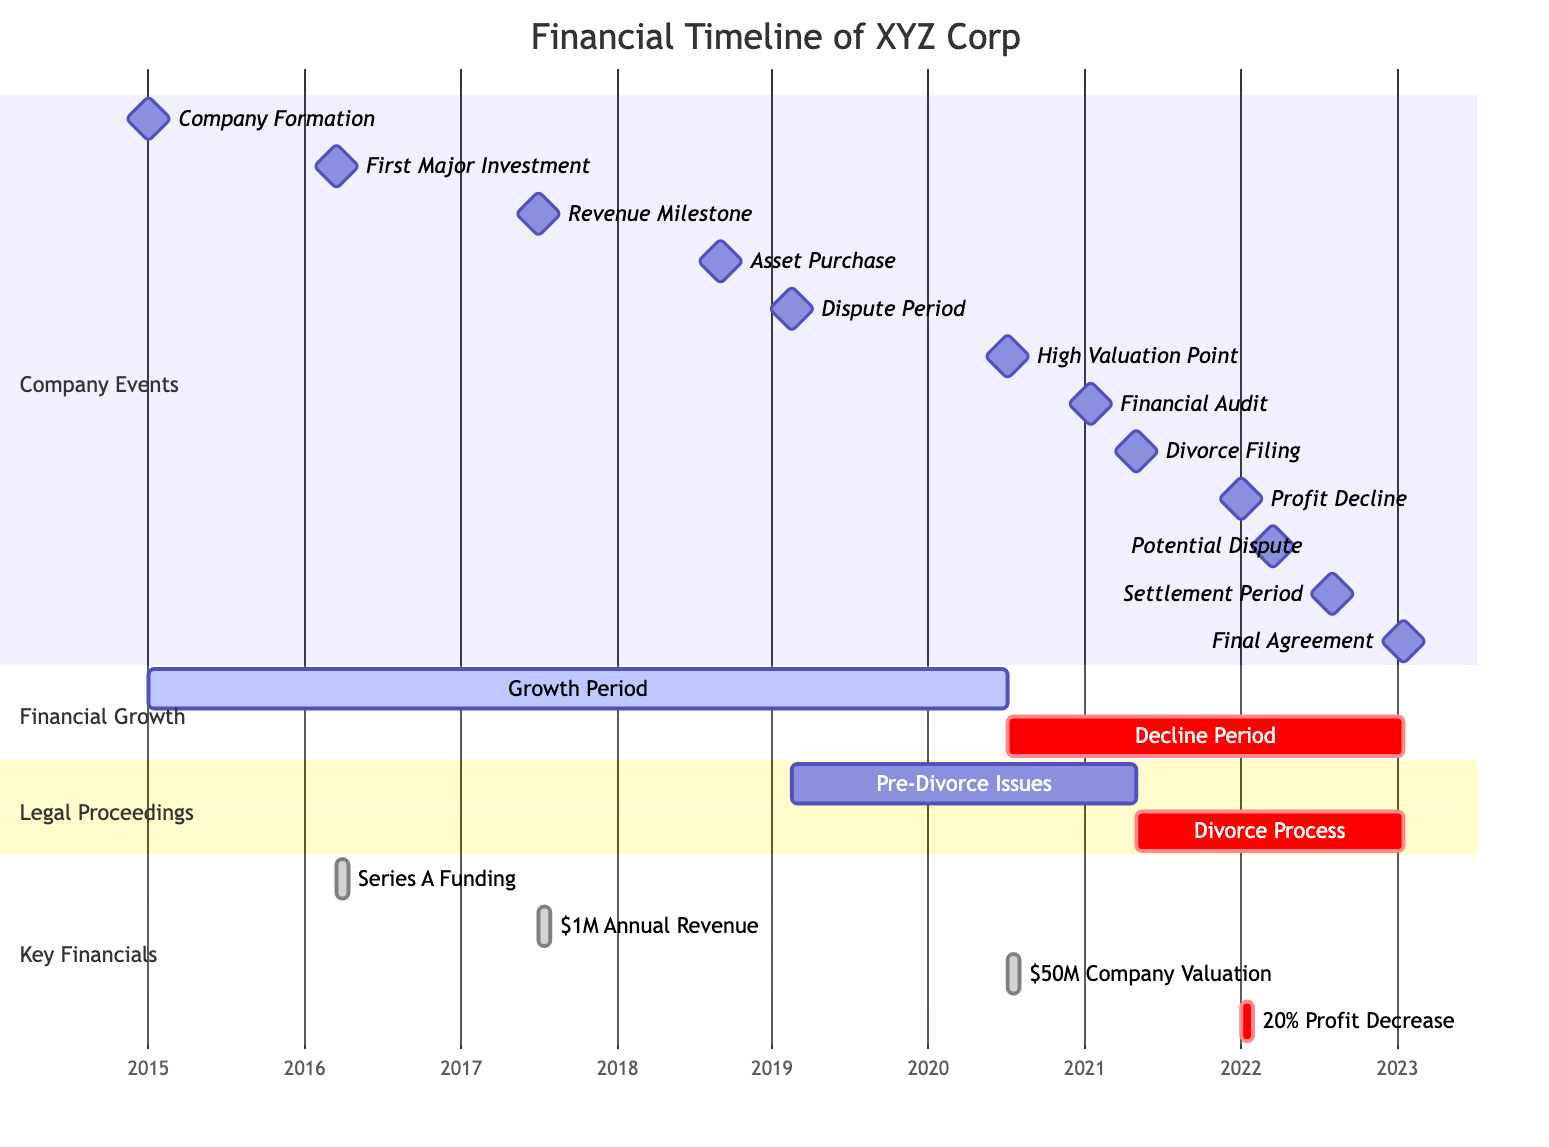What is the year of the company's formation? The diagram clearly indicates the company formation date marked as a milestone, which is noted as January 1, 2015.
Answer: 2015 Which event happened immediately after the first major investment? The first major investment occurred on March 15, 2016, followed by the revenue milestone, which was achieved on June 30, 2017. Thus, the revenue milestone is the event that directly followed the investment.
Answer: Revenue Milestone What is the duration of the decline period? The decline period starts from July 1, 2020, to January 15, 2023. To find the duration, we calculate the time between these two dates. This results in a total duration of about 2 years and 6.5 months (July 2020 to January 2023).
Answer: 2 years and 6.5 months How many critical periods are shown in the diagram? The diagram includes a section labeled "Financial Growth" which notes 'Decline Period' as critical, and within "Key Financials," there is a '20% Profit Decrease' noted as critical. Additionally, "Divorce Process" is marked as critical. Thus, we can count three periods classified as critical.
Answer: 3 What major event coincides with the divorce filing? The divorce filing is marked as May 1, 2021. The preceding milestone of 'Financial Audit' occurred on January 15, 2021, and the 'Profit Decline' happens at the end of the same year. Therefore, the 'Divorce Process' begins on the filing date, indicating it's directly related to the couple's legal situation.
Answer: Divorce Process What is the financial status right before the potential dispute? The potential dispute is scheduled for March 15, 2022. Leading up to this, the most relevant event before this date is the profit decline which was recorded on December 31, 2021. Therefore, the financial status before the potential dispute reflects a declining profitability context.
Answer: Profit Decline What was the company's valuation at its high point? The high valuation point is specifically stated as July 1, 2020, and it notes a company valuation of $50M at that date. This milestone encapsulates the apex of the company's financial valuation.
Answer: $50M Which sections of the diagram depict overlapping timelines? The "Legal Proceedings" and "Financial Growth" sections overlap in terms of timeline events with critical junctures drawn across many milestones intersecting, particularly around bankruptcy, disputes, and potential impacts on financials. Both sections provide overlapping timelines between legal issues and financial performance.
Answer: Legal Proceedings and Financial Growth What action was taken immediately before the financial audit? Prior to the financial audit that occurred on January 15, 2021, the last notable event in the timeline was the onset of the divorce filing on May 1, 2021. Thus, the action taken immediately before the audit is related to managing assets in contemplation of divorce.
Answer: Divorce Filing 